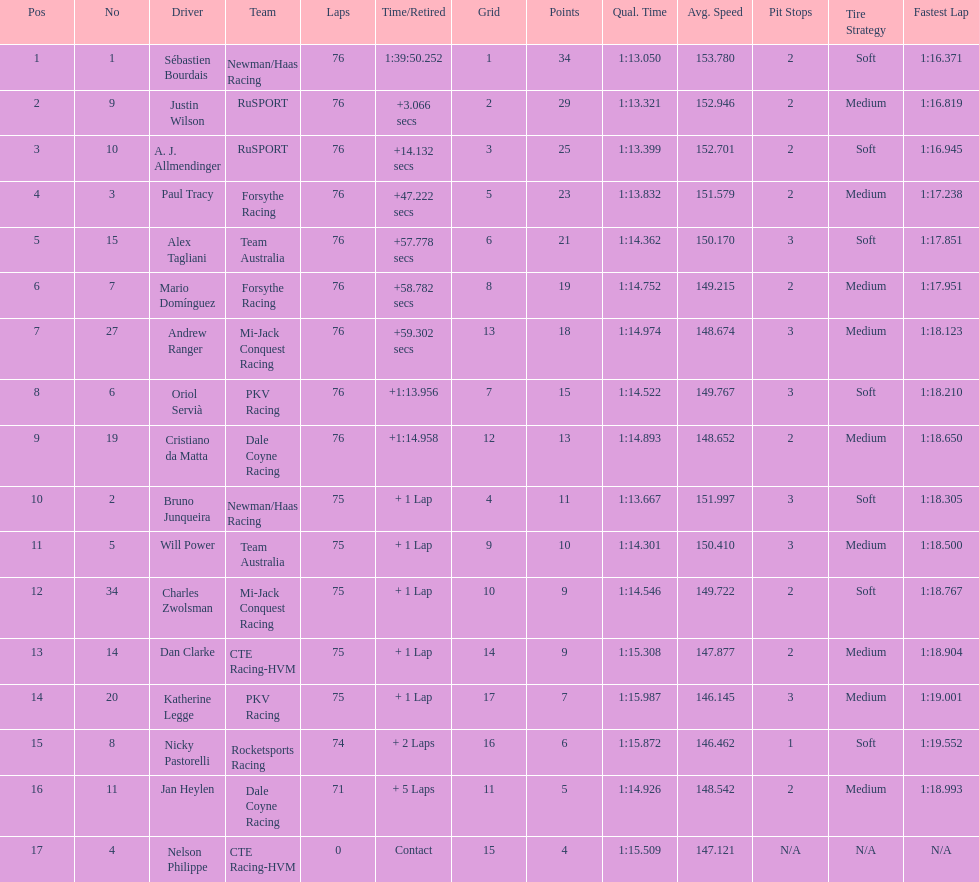Which canadian driver finished first: alex tagliani or paul tracy? Paul Tracy. 